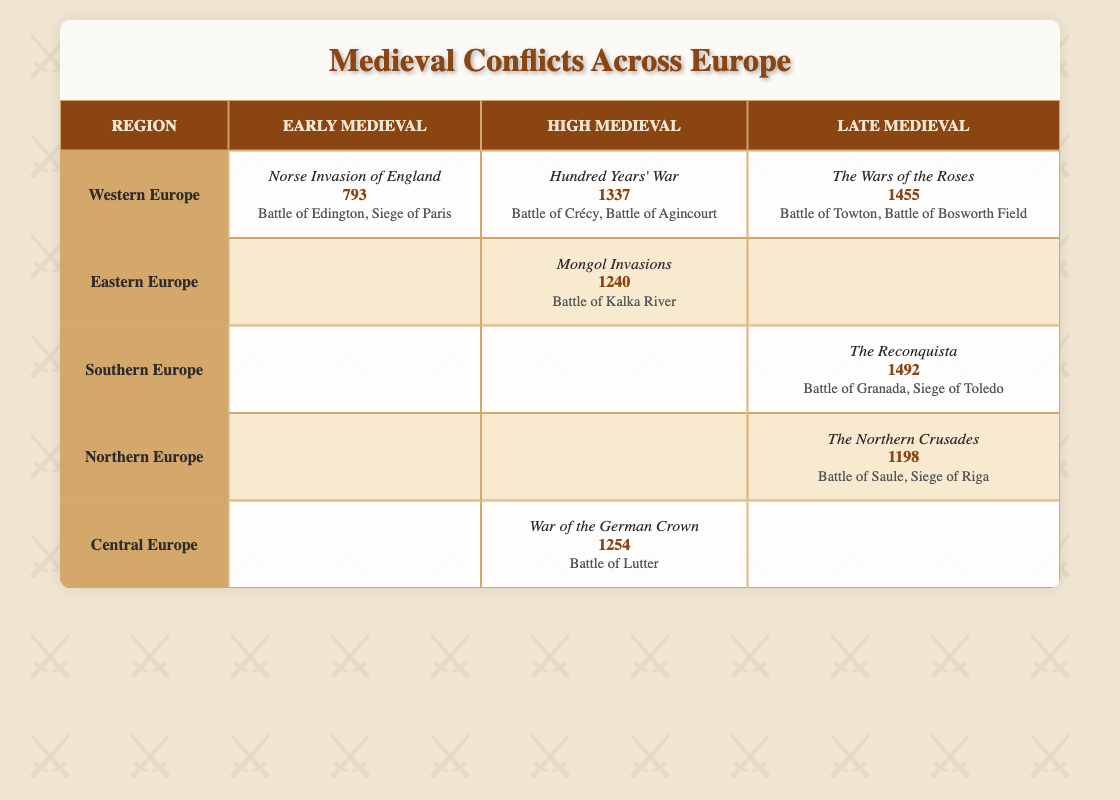What is the conflict listed for Eastern Europe in the High Medieval era? The table shows that in the High Medieval era, the conflict listed for Eastern Europe is the Mongol Invasions. This can be directly found under the Eastern Europe row and the High Medieval column.
Answer: Mongol Invasions How many conflicts are documented in Western Europe during the Late Medieval period? In the Late Medieval period, Western Europe has one documented conflict, which is The Wars of the Roses. This is found in the Western Europe row under the Late Medieval column.
Answer: 1 What was the year of The Reconquista in Southern Europe? The Reconquista in Southern Europe is listed in the Late Medieval period with the year 1492. This can be retrieved directly from the Southern Europe row and the Late Medieval column.
Answer: 1492 Are there any conflicts listed for Northern Europe in the High Medieval era? The table reveals that there are no conflicts documented for Northern Europe during the High Medieval era, as the corresponding cell in that column is blank.
Answer: No Which region experienced the earliest conflict and what was the year of that conflict? The earliest conflict listed in the table is the Norse Invasion of England in the year 793, which can be found in the Western Europe row under the Early Medieval column. This represents the first recorded conflict chronologically in the dataset.
Answer: 793 Count the total number of documented conflicts across all regions in the Late Medieval period. In the Late Medieval period, the table lists three conflicts: The Reconquista (Southern Europe), The Northern Crusades (Northern Europe), and The Wars of the Roses (Western Europe). Therefore, summing these gives a total of three documented conflicts in the Late Medieval period.
Answer: 3 Which region(s) had conflicts noted in both the High Medieval and Late Medieval eras? Upon examining the table, Western Europe is the only region with documented conflicts in both the High Medieval (Hundred Years' War) and Late Medieval (The Wars of the Roses) eras. There are no other regions that have entries in both categories.
Answer: Western Europe What is the relationship between the years of the conflicts in Eastern Europe and Central Europe? The year of the Mongol Invasions in Eastern Europe is 1240, while the year of the War of the German Crown in Central Europe is 1254. The relationship shows that the conflict in Central Europe occurred 14 years after the conflict in Eastern Europe. This indicates potential chronological proximity in the broader context of medieval conflicts.
Answer: 14 years apart What can we deduce about the geographical distribution of conflicts in Medieval Europe based on this table? The table indicates that conflicts are distributed across all regions of Medieval Europe, but Western Europe has the highest number of conflicts documented (three), which may suggest it was a hotspot of conflict during the Middle Ages. Other regions like Southern Europe also show significant conflict (The Reconquista), while Eastern and Northern Europe have fewer documented conflicts, hinting at varied conflict intensity geographically.
Answer: Western Europe had the most conflicts 